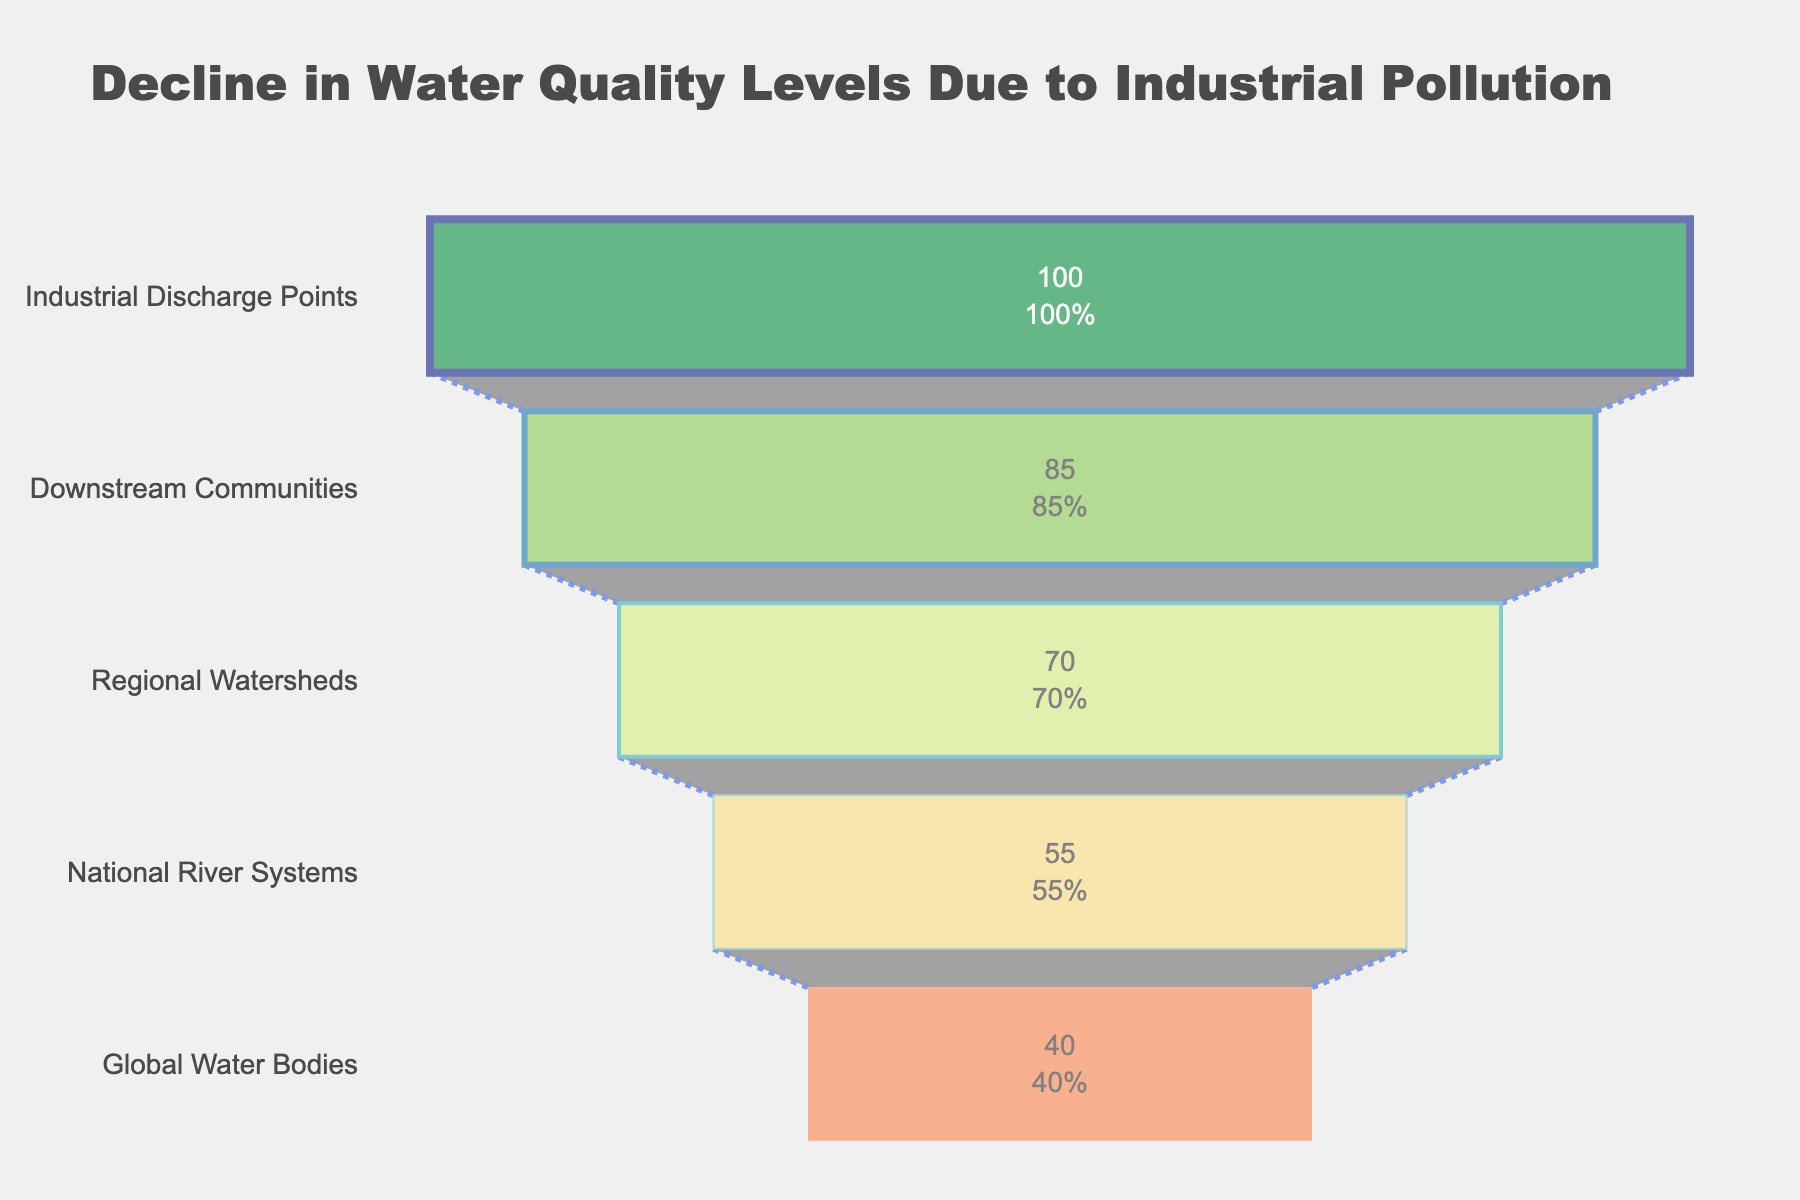what is the title of the funnel chart? The title is located at the top center of the chart. It is "Decline in Water Quality Levels Due to Industrial Pollution".
Answer: Decline in Water Quality Levels Due to Industrial Pollution how many stages are represented in the funnel chart? Count the number of distinct stages listed on the y-axis of the funnel chart. There are 5 stages.
Answer: 5 which stage has the highest percentage of polluted rivers and what is the percentage? The highest percentage is at the top of the funnel chart. The stage is "Industrial Discharge Points" with 100%.
Answer: Industrial Discharge Points, 100% what is the percentage decline in water quality between 'Regional Watersheds' and 'National River Systems'? Subtract the percentage of 'National River Systems' from 'Regional Watersheds'. It is 70% - 55% = 15%.
Answer: 15% which stage shows the lowest percentage of polluted rivers and what is this percentage? The lowest percentage is at the bottom of the funnel chart. The stage is "Global Water Bodies" with 40%.
Answer: Global Water Bodies, 40% what is the visual color gradient for the stages as depicted in the funnel chart? Observe the color scheme from top to bottom of the funnel chart. The colors change from dark green to light green and then to orange and red shades.
Answer: Dark green to light green to orange to red how much does the percentage of polluted rivers reduce from 'Industrial Discharge Points' to 'National River Systems'? Subtract the percentage of 'National River Systems' from 'Industrial Discharge Points'. It is 100% - 55% = 45%.
Answer: 45% compare the percentage of polluted rivers between the 'Downstream Communities' and 'Global Water Bodies' stages. The percentage for 'Downstream Communities' is 85% and for 'Global Water Bodies' is 40%. 85% is greater than 40%.
Answer: 85% > 40% what is the overall decline in river water quality percentage from the first stage to the last stage in the chart? Subtract the percentage of 'Global Water Bodies' from 'Industrial Discharge Points'. It is 100% - 40% = 60%.
Answer: 60% how would you describe the pattern or trend shown in the funnel chart regarding water quality levels? The percentages decrease consistently at each stage, indicating a worsening of water quality as you progress from industrial discharge points through to global water bodies.
Answer: Continuous decline 